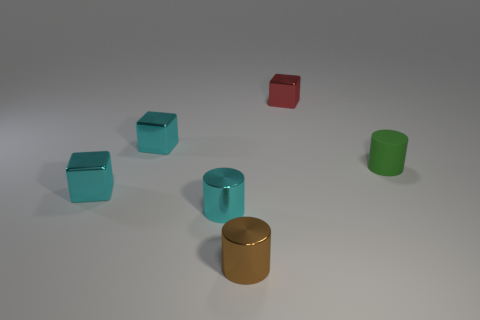Is there a shiny cube that has the same size as the brown object?
Your response must be concise. Yes. There is a cyan object that is the same shape as the brown object; what material is it?
Provide a succinct answer. Metal. There is a brown shiny object that is the same size as the cyan cylinder; what is its shape?
Ensure brevity in your answer.  Cylinder. Is there another metallic object of the same shape as the tiny green thing?
Your answer should be compact. Yes. What is the shape of the tiny cyan metallic object that is behind the cylinder right of the tiny red object?
Make the answer very short. Cube. The small red shiny object has what shape?
Your answer should be compact. Cube. The tiny cyan block that is behind the thing that is on the right side of the shiny block that is to the right of the brown metal cylinder is made of what material?
Offer a very short reply. Metal. What number of other things are there of the same material as the tiny green object
Provide a succinct answer. 0. How many small green rubber things are behind the small thing that is right of the red shiny object?
Keep it short and to the point. 0. How many cubes are either cyan things or small brown objects?
Offer a terse response. 2. 